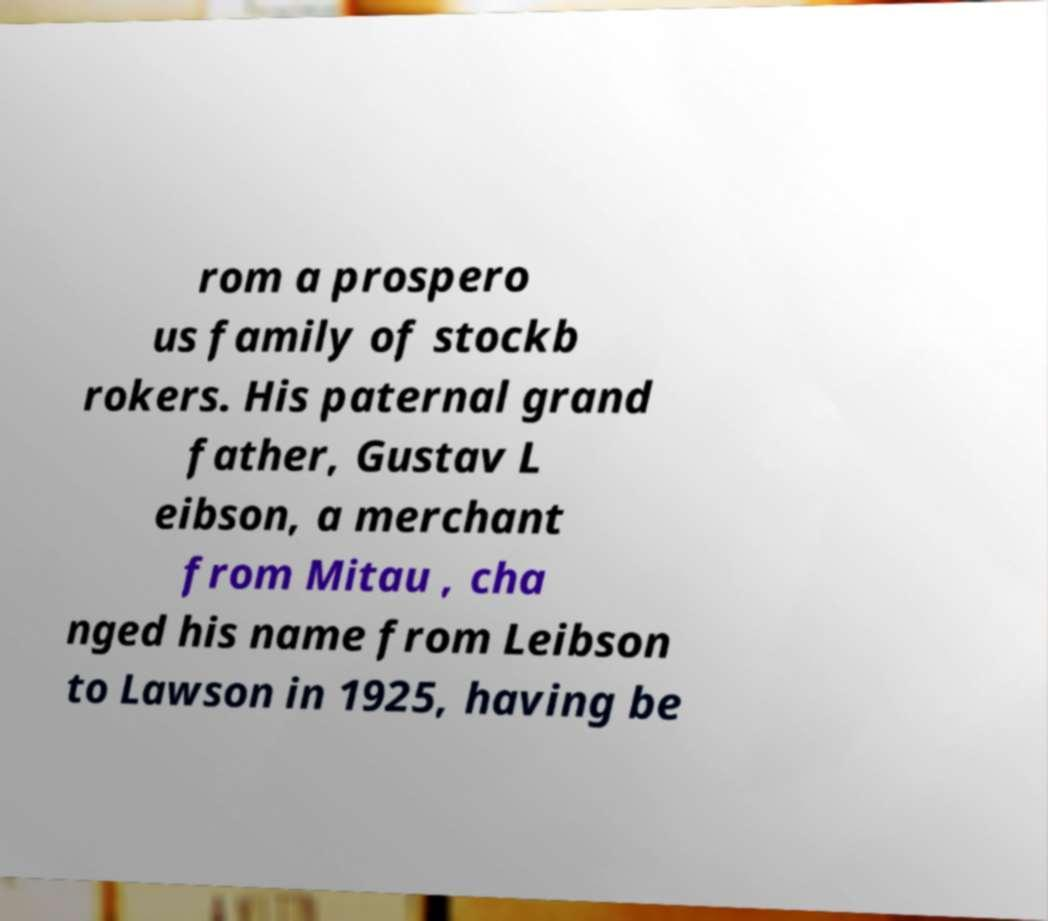Can you accurately transcribe the text from the provided image for me? rom a prospero us family of stockb rokers. His paternal grand father, Gustav L eibson, a merchant from Mitau , cha nged his name from Leibson to Lawson in 1925, having be 